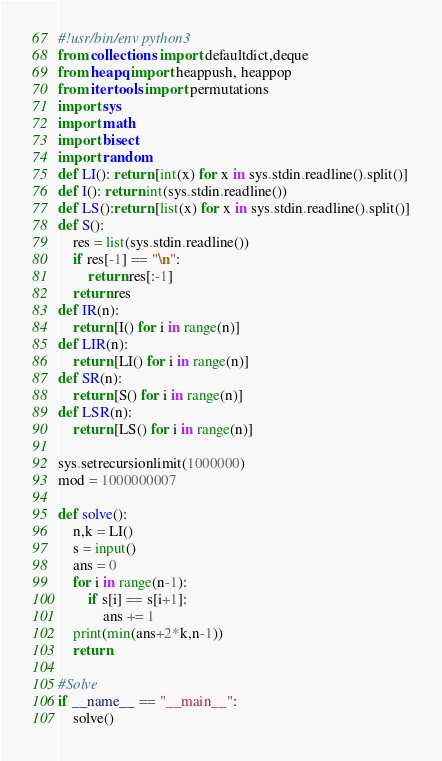Convert code to text. <code><loc_0><loc_0><loc_500><loc_500><_Python_>#!usr/bin/env python3
from collections import defaultdict,deque
from heapq import heappush, heappop
from itertools import permutations
import sys
import math
import bisect
import random
def LI(): return [int(x) for x in sys.stdin.readline().split()]
def I(): return int(sys.stdin.readline())
def LS():return [list(x) for x in sys.stdin.readline().split()]
def S():
    res = list(sys.stdin.readline())
    if res[-1] == "\n":
        return res[:-1]
    return res
def IR(n):
    return [I() for i in range(n)]
def LIR(n):
    return [LI() for i in range(n)]
def SR(n):
    return [S() for i in range(n)]
def LSR(n):
    return [LS() for i in range(n)]

sys.setrecursionlimit(1000000)
mod = 1000000007

def solve():
    n,k = LI()
    s = input()
    ans = 0
    for i in range(n-1):
        if s[i] == s[i+1]:
            ans += 1
    print(min(ans+2*k,n-1))
    return

#Solve
if __name__ == "__main__":
    solve()
</code> 